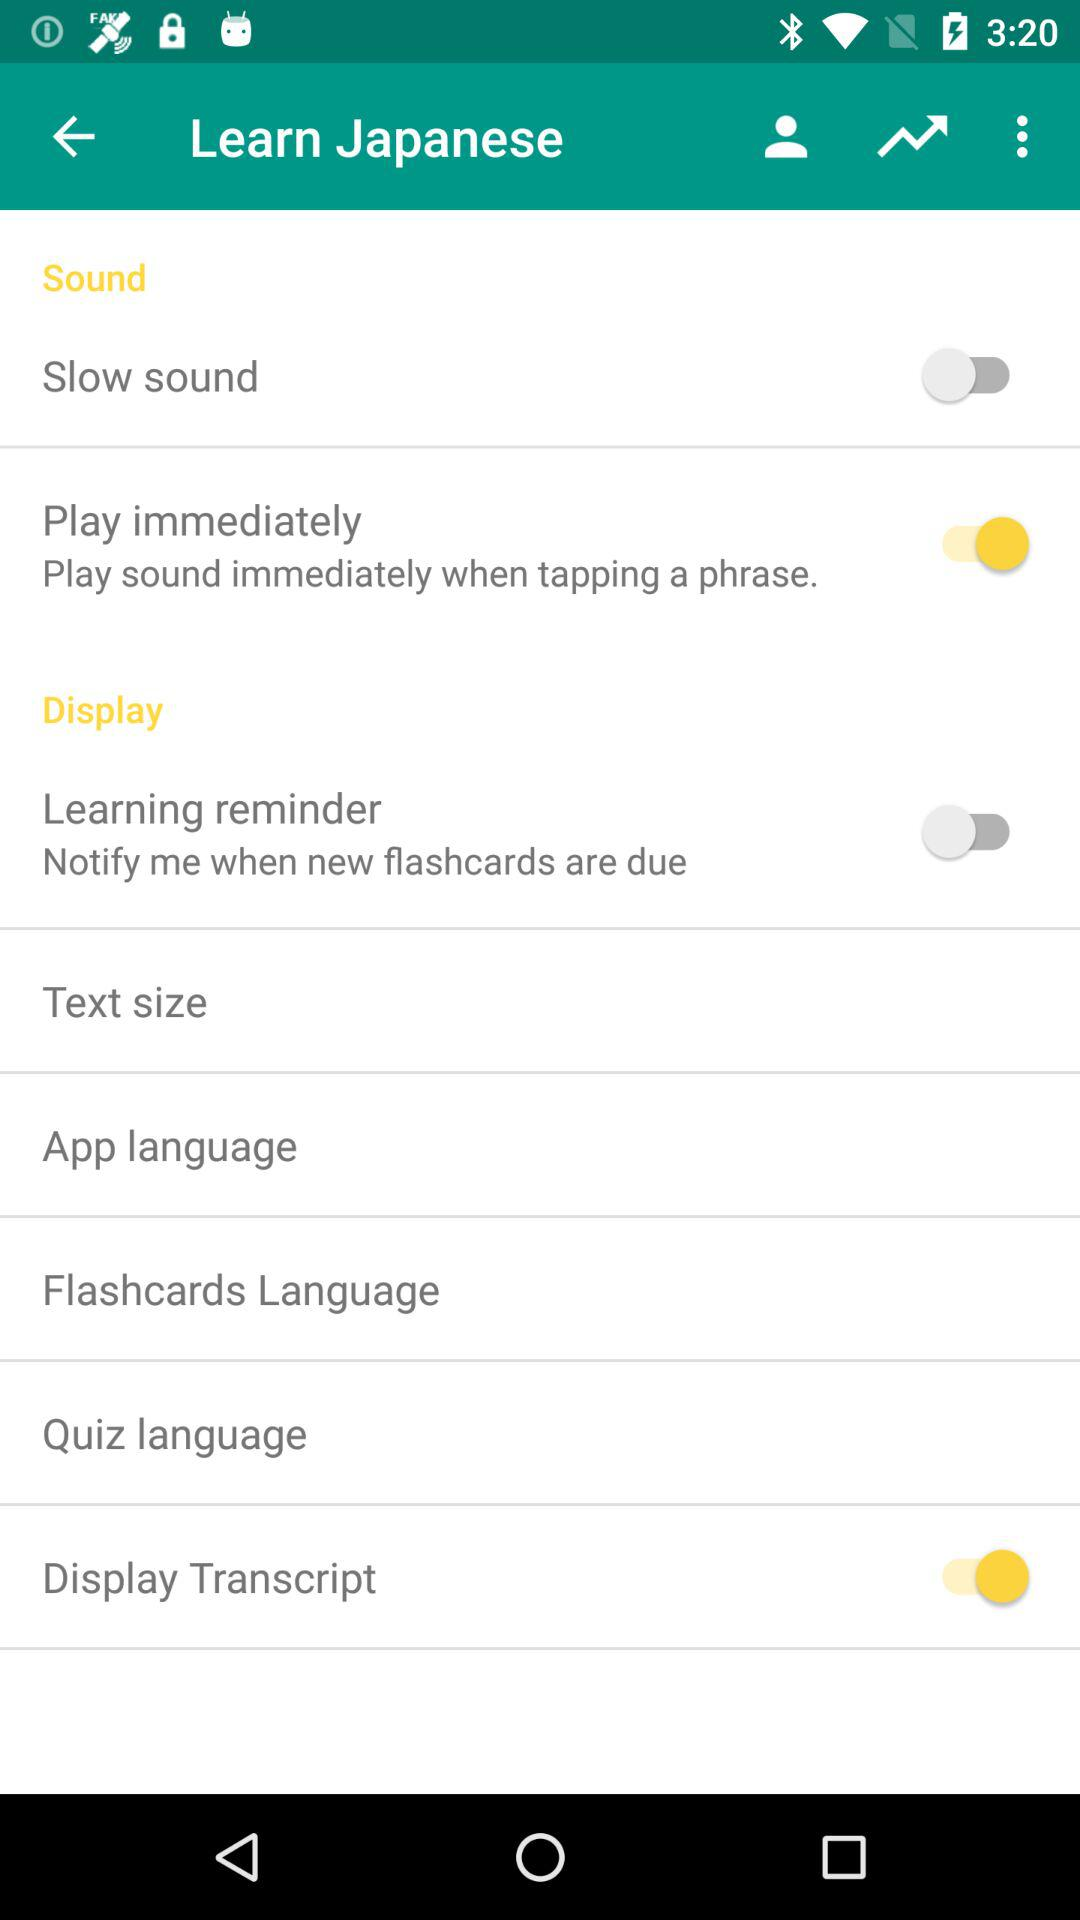What options are available for adjusting the display on the app? The options available for adjusting the display include 'Text size' and 'Display Transcript' which allow customization of readability within the app. 